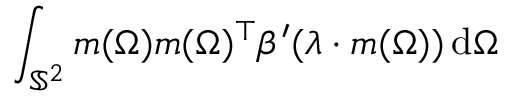<formula> <loc_0><loc_0><loc_500><loc_500>\int _ { \mathbb { S } ^ { 2 } } m ( \Omega ) m ( \Omega ) ^ { \top } \beta ^ { \prime } ( \lambda \cdot m ( \Omega ) ) \, d \Omega</formula> 